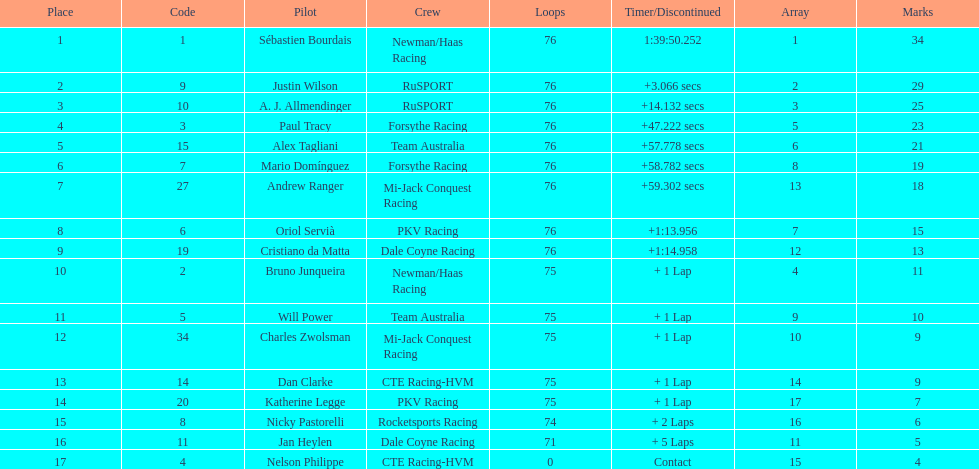Who drove during the 2006 tecate grand prix of monterrey? Sébastien Bourdais, Justin Wilson, A. J. Allmendinger, Paul Tracy, Alex Tagliani, Mario Domínguez, Andrew Ranger, Oriol Servià, Cristiano da Matta, Bruno Junqueira, Will Power, Charles Zwolsman, Dan Clarke, Katherine Legge, Nicky Pastorelli, Jan Heylen, Nelson Philippe. And what were their finishing positions? 1, 2, 3, 4, 5, 6, 7, 8, 9, 10, 11, 12, 13, 14, 15, 16, 17. Who did alex tagliani finish directly behind of? Paul Tracy. 